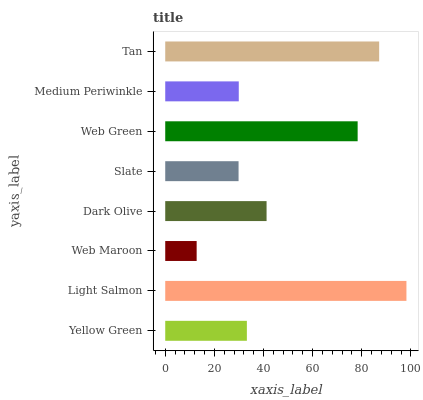Is Web Maroon the minimum?
Answer yes or no. Yes. Is Light Salmon the maximum?
Answer yes or no. Yes. Is Light Salmon the minimum?
Answer yes or no. No. Is Web Maroon the maximum?
Answer yes or no. No. Is Light Salmon greater than Web Maroon?
Answer yes or no. Yes. Is Web Maroon less than Light Salmon?
Answer yes or no. Yes. Is Web Maroon greater than Light Salmon?
Answer yes or no. No. Is Light Salmon less than Web Maroon?
Answer yes or no. No. Is Dark Olive the high median?
Answer yes or no. Yes. Is Yellow Green the low median?
Answer yes or no. Yes. Is Slate the high median?
Answer yes or no. No. Is Dark Olive the low median?
Answer yes or no. No. 